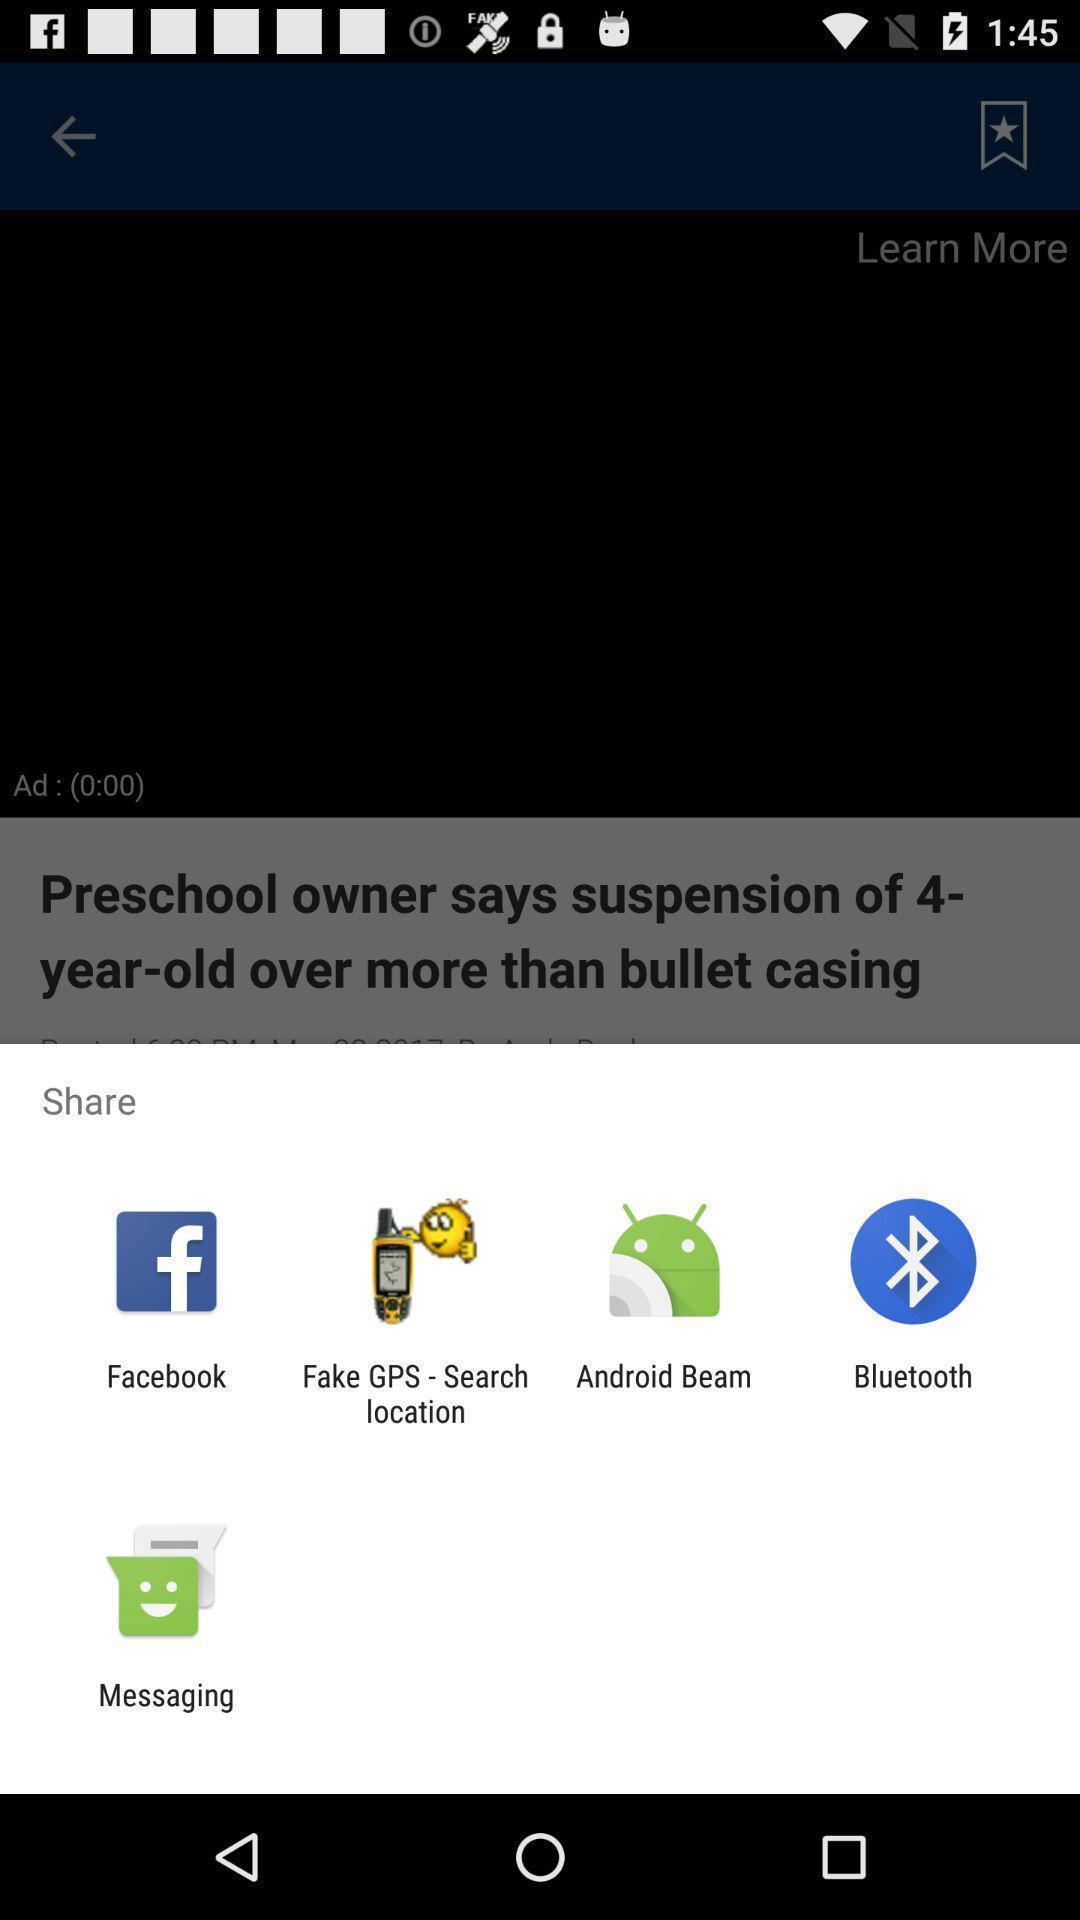Describe the content in this image. Widget showing different sharing applications. 